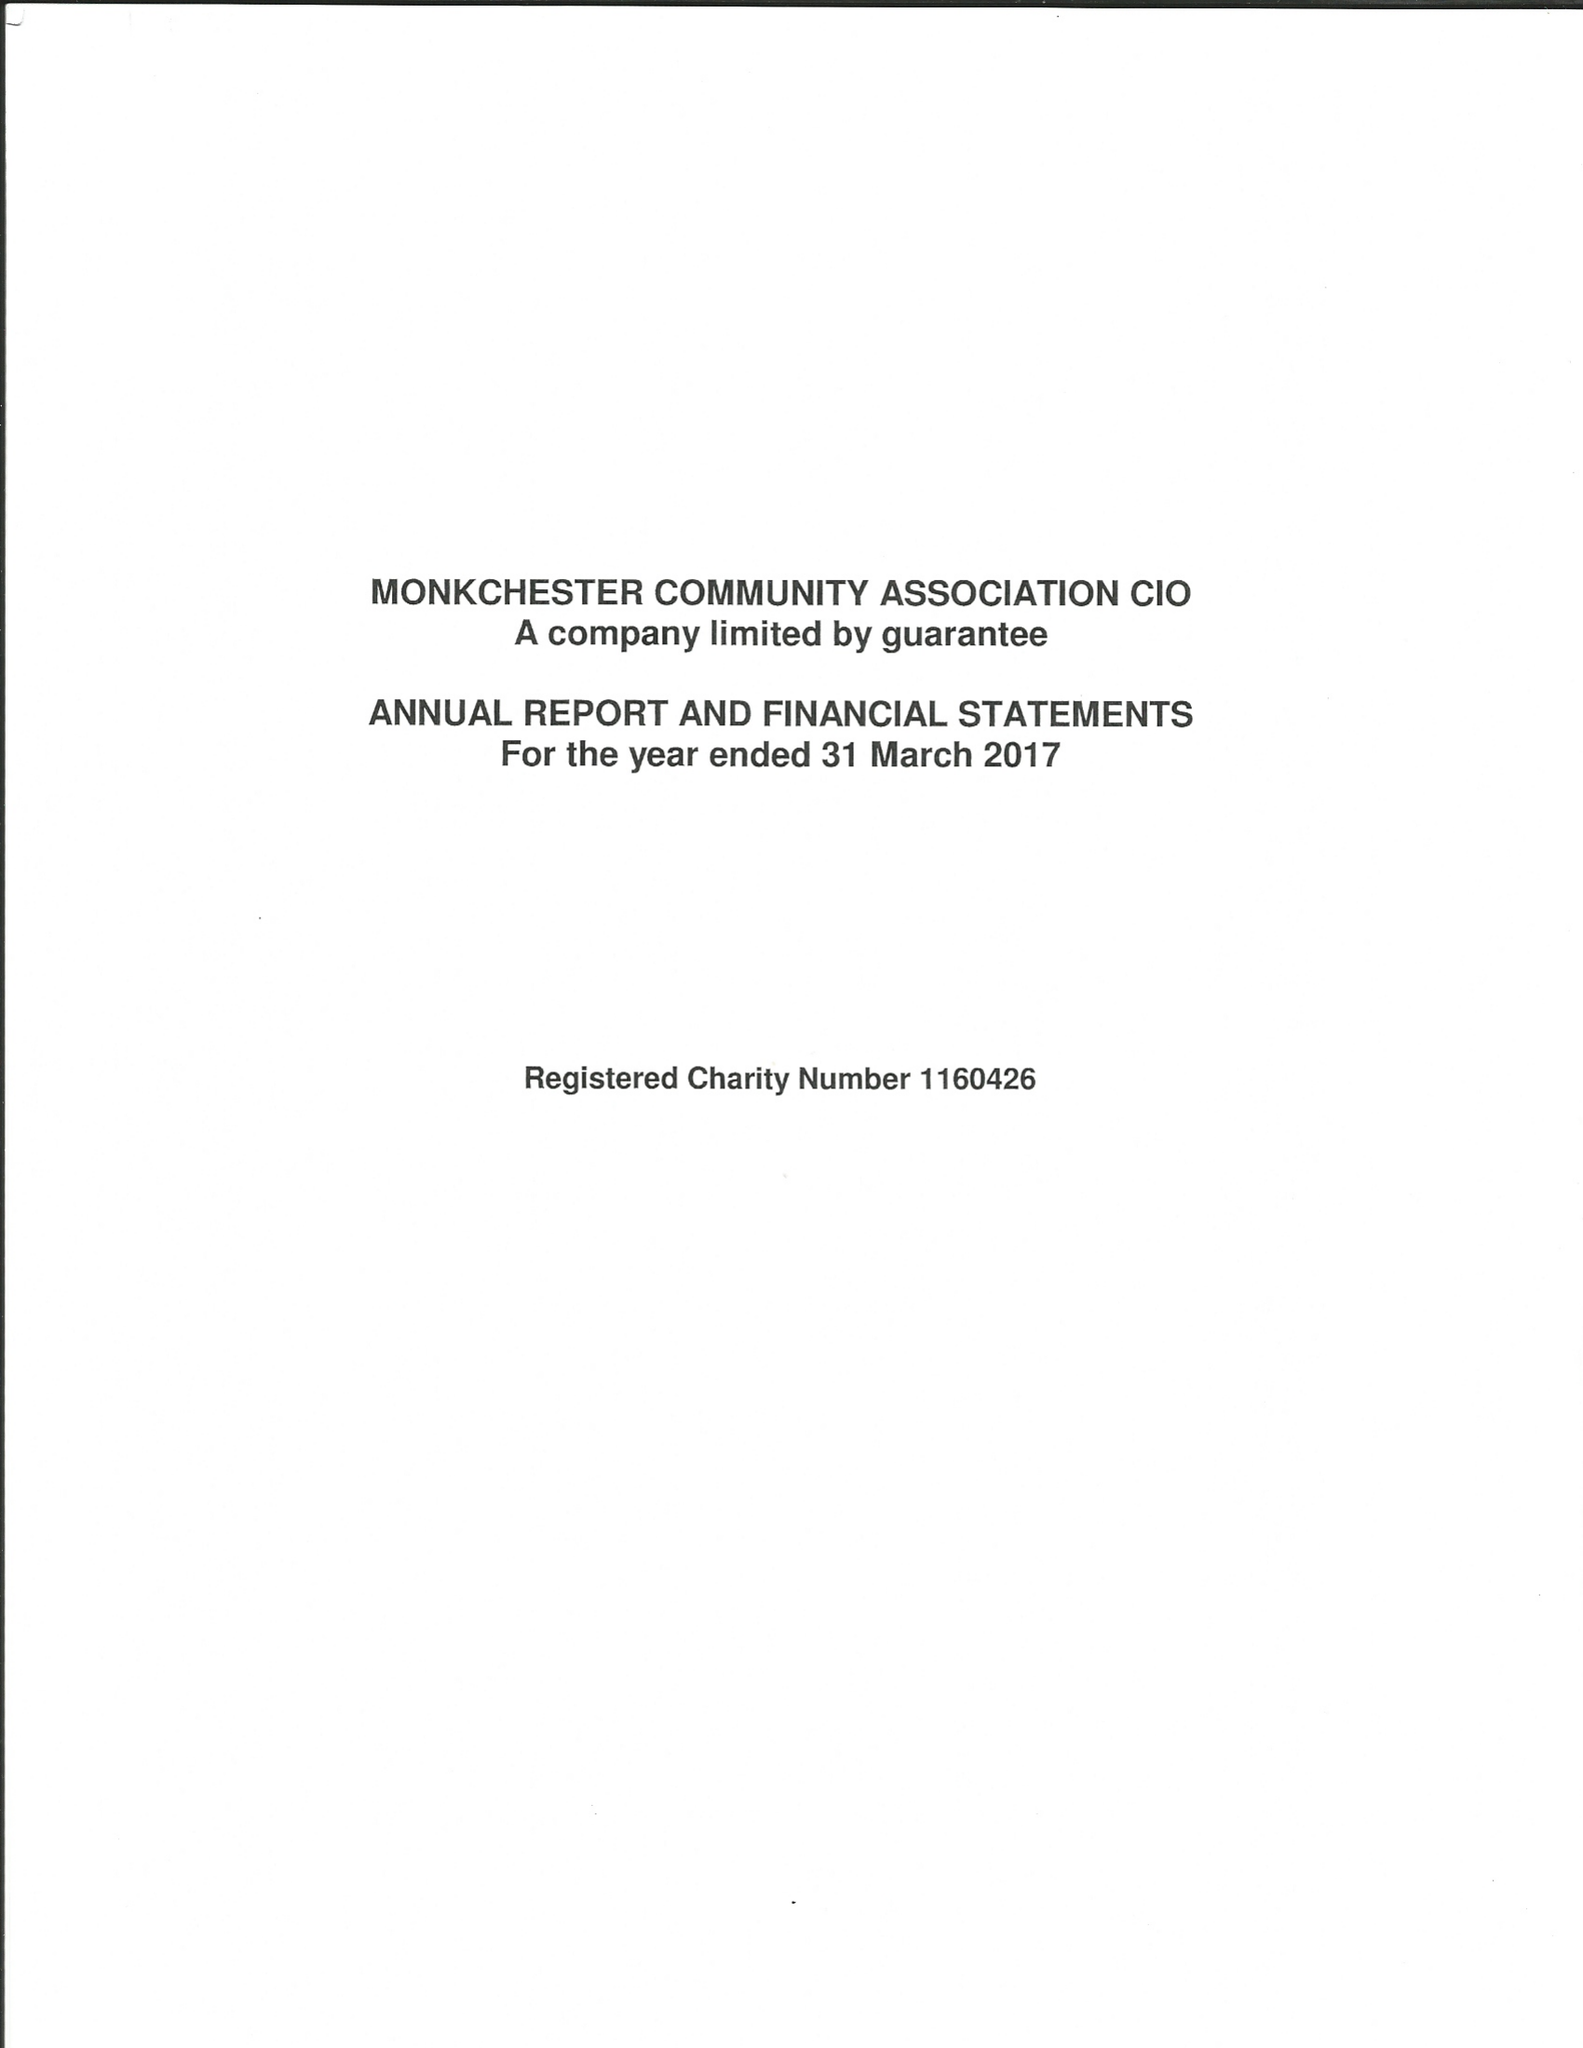What is the value for the spending_annually_in_british_pounds?
Answer the question using a single word or phrase. 13033.00 